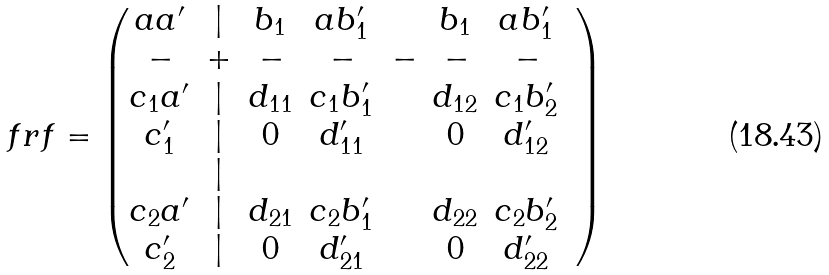Convert formula to latex. <formula><loc_0><loc_0><loc_500><loc_500>\ f r f = \begin{pmatrix} a a ^ { \prime } & | & b _ { 1 } & a b _ { 1 } ^ { \prime } & & b _ { 1 } & a b _ { 1 } ^ { \prime } \\ - & + & - & - & - & - & - \\ c _ { 1 } a ^ { \prime } & | & d _ { 1 1 } & c _ { 1 } b _ { 1 } ^ { \prime } & & d _ { 1 2 } & c _ { 1 } b _ { 2 } ^ { \prime } \\ c ^ { \prime } _ { 1 } & | & 0 & d _ { 1 1 } ^ { \prime } & & 0 & d _ { 1 2 } ^ { \prime } & \\ & | & & & & \\ c _ { 2 } a ^ { \prime } & | & d _ { 2 1 } & c _ { 2 } b _ { 1 } ^ { \prime } & & d _ { 2 2 } & c _ { 2 } b _ { 2 } ^ { \prime } \\ c ^ { \prime } _ { 2 } & | & 0 & d _ { 2 1 } ^ { \prime } & & 0 & d _ { 2 2 } ^ { \prime } & \end{pmatrix}</formula> 